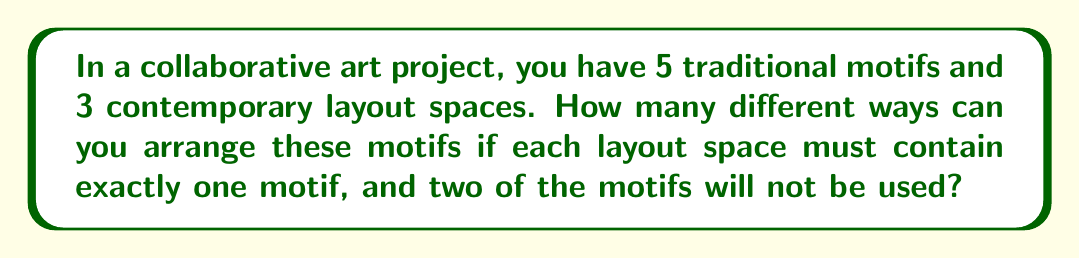What is the answer to this math problem? Let's approach this step-by-step:

1) First, we need to choose which 3 motifs out of the 5 will be used. This is a combination problem, denoted as $\binom{5}{3}$ or $C(5,3)$.

   $$\binom{5}{3} = \frac{5!}{3!(5-3)!} = \frac{5!}{3!2!} = 10$$

2) Now that we have chosen 3 motifs, we need to arrange them in the 3 layout spaces. This is a permutation of 3 objects, which is simply $3!$.

   $$3! = 3 \times 2 \times 1 = 6$$

3) By the multiplication principle, the total number of ways to arrange the motifs is the product of the number of ways to choose the motifs and the number of ways to arrange them:

   $$10 \times 6 = 60$$

Therefore, there are 60 different ways to arrange the traditional motifs in the contemporary layout.
Answer: 60 